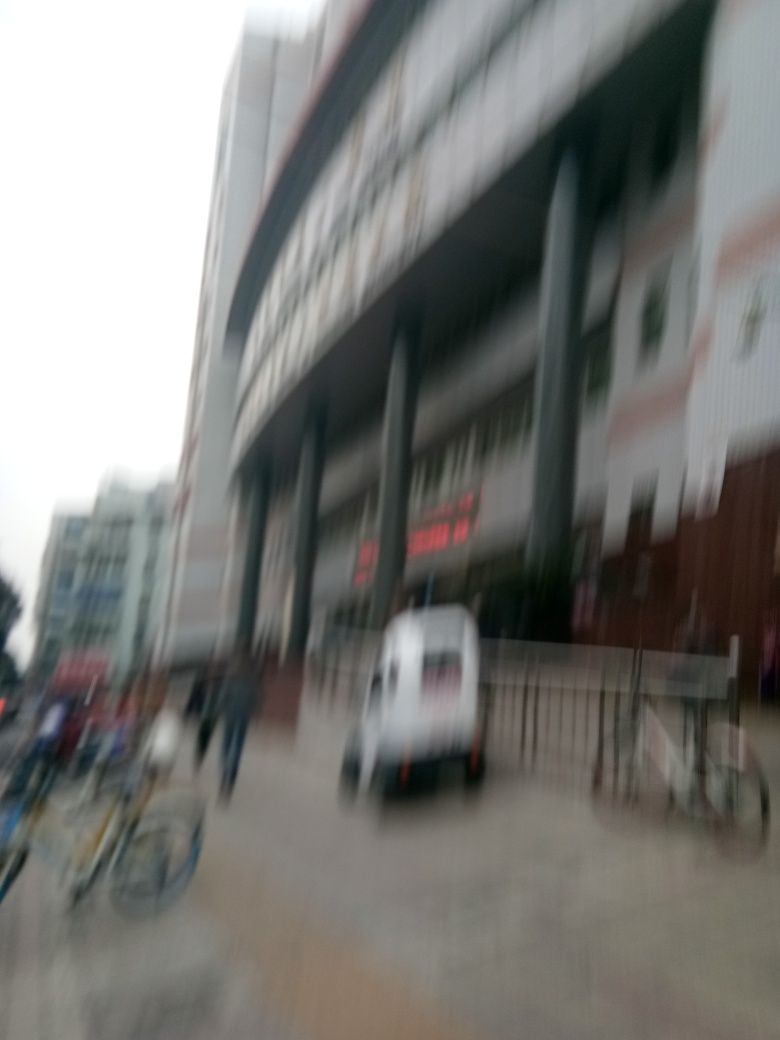What kind of location is shown in this image? Though it's blurred, the structure appears to be a large building with signage, hinting it might be a commercial or public space, such as a shopping center or a train station. 